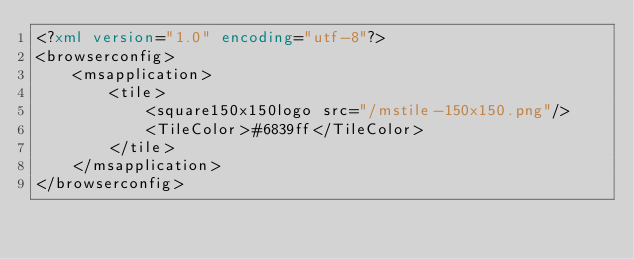<code> <loc_0><loc_0><loc_500><loc_500><_XML_><?xml version="1.0" encoding="utf-8"?>
<browserconfig>
    <msapplication>
        <tile>
            <square150x150logo src="/mstile-150x150.png"/>
            <TileColor>#6839ff</TileColor>
        </tile>
    </msapplication>
</browserconfig>
</code> 